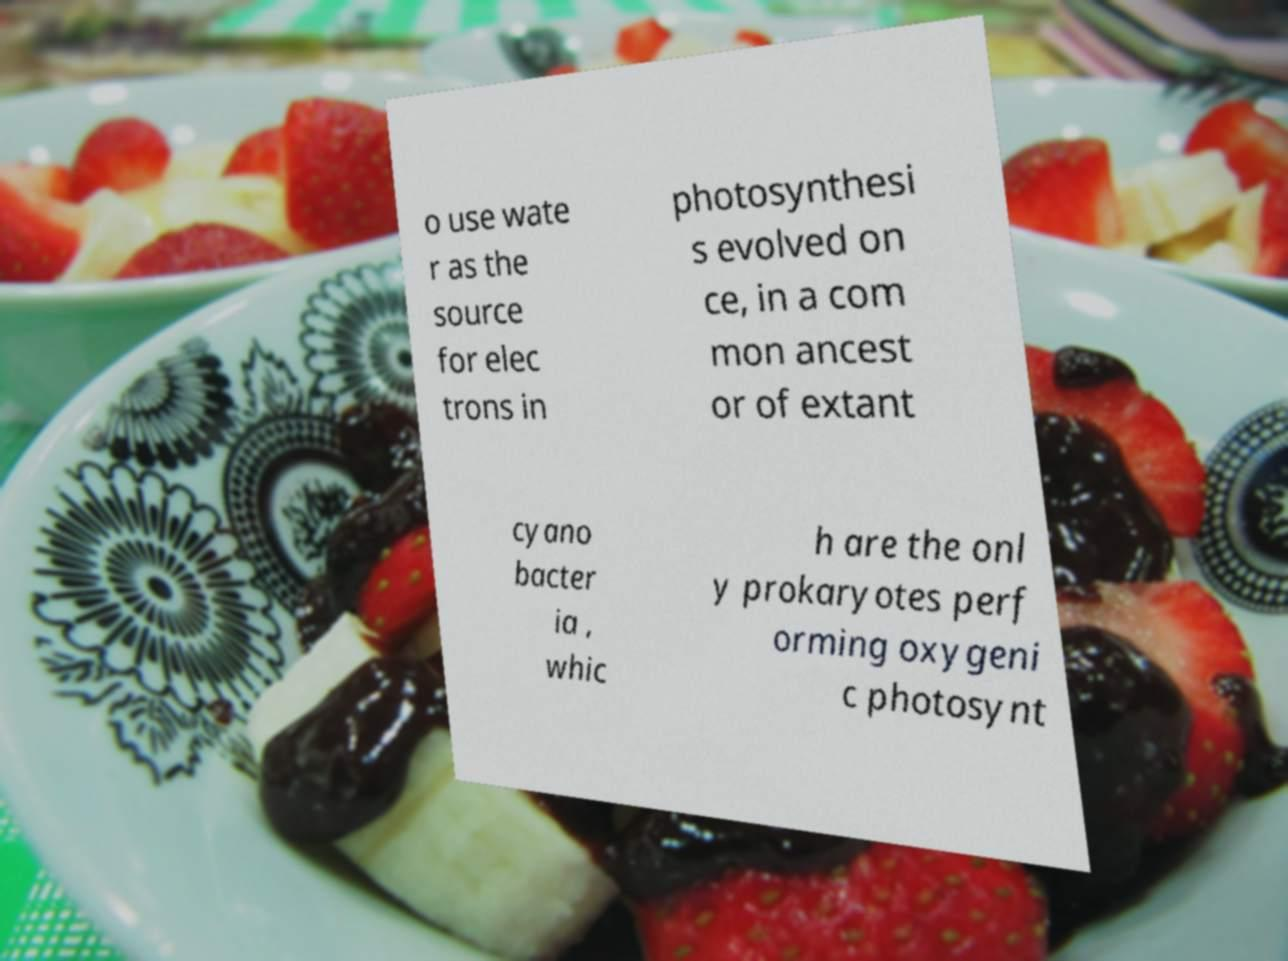Can you read and provide the text displayed in the image?This photo seems to have some interesting text. Can you extract and type it out for me? o use wate r as the source for elec trons in photosynthesi s evolved on ce, in a com mon ancest or of extant cyano bacter ia , whic h are the onl y prokaryotes perf orming oxygeni c photosynt 